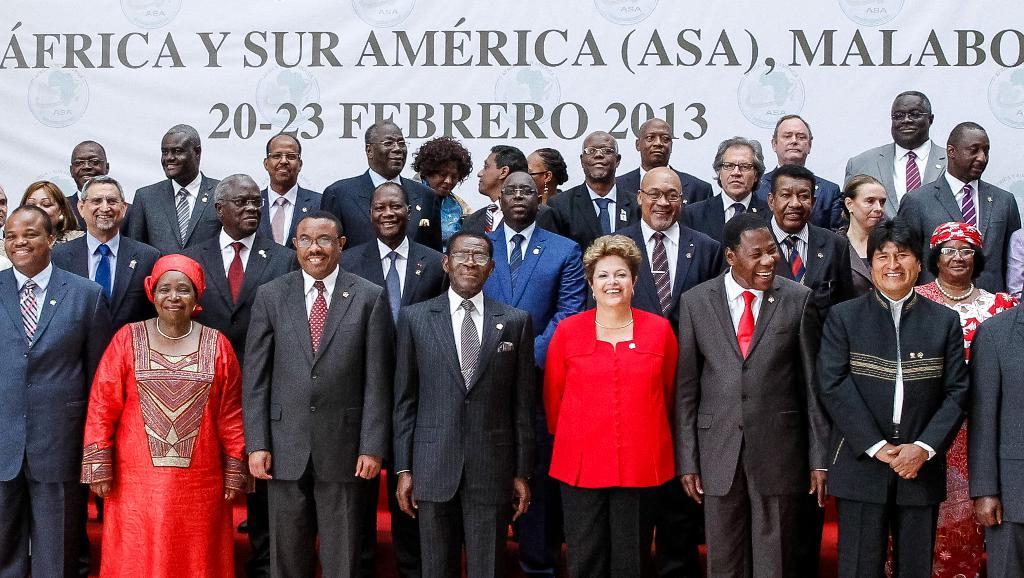What is happening in the image? There are people standing in the image. What can be seen in the background of the image? There is a banner with text in the background of the image. What type of plantation is visible in the image? There is no plantation present in the image. What nation is represented by the people in the image? The image does not provide information about the nationality of the people. 